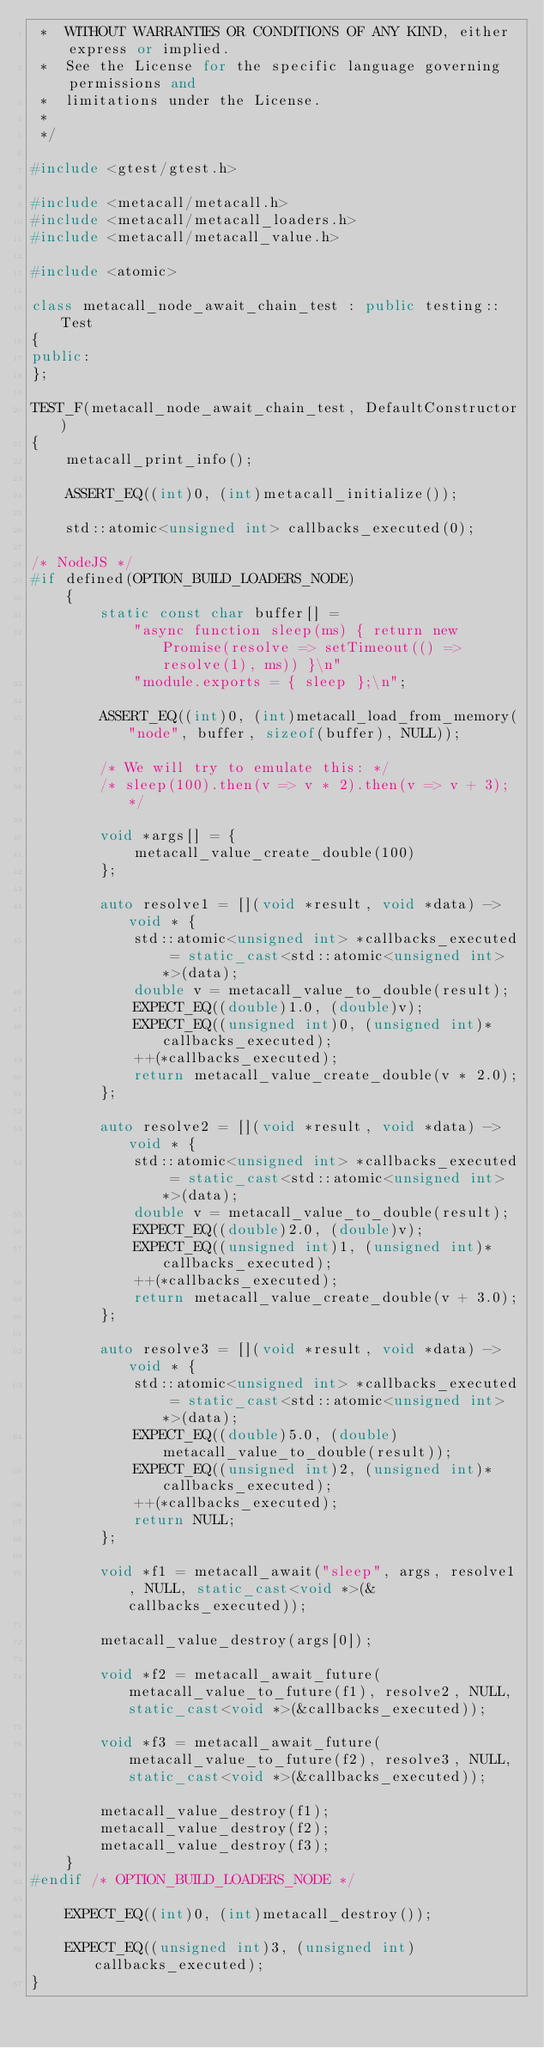Convert code to text. <code><loc_0><loc_0><loc_500><loc_500><_C++_> *	WITHOUT WARRANTIES OR CONDITIONS OF ANY KIND, either express or implied.
 *	See the License for the specific language governing permissions and
 *	limitations under the License.
 *
 */

#include <gtest/gtest.h>

#include <metacall/metacall.h>
#include <metacall/metacall_loaders.h>
#include <metacall/metacall_value.h>

#include <atomic>

class metacall_node_await_chain_test : public testing::Test
{
public:
};

TEST_F(metacall_node_await_chain_test, DefaultConstructor)
{
	metacall_print_info();

	ASSERT_EQ((int)0, (int)metacall_initialize());

	std::atomic<unsigned int> callbacks_executed(0);

/* NodeJS */
#if defined(OPTION_BUILD_LOADERS_NODE)
	{
		static const char buffer[] =
			"async function sleep(ms) { return new Promise(resolve => setTimeout(() => resolve(1), ms)) }\n"
			"module.exports = { sleep };\n";

		ASSERT_EQ((int)0, (int)metacall_load_from_memory("node", buffer, sizeof(buffer), NULL));

		/* We will try to emulate this: */
		/* sleep(100).then(v => v * 2).then(v => v + 3); */

		void *args[] = {
			metacall_value_create_double(100)
		};

		auto resolve1 = [](void *result, void *data) -> void * {
			std::atomic<unsigned int> *callbacks_executed = static_cast<std::atomic<unsigned int> *>(data);
			double v = metacall_value_to_double(result);
			EXPECT_EQ((double)1.0, (double)v);
			EXPECT_EQ((unsigned int)0, (unsigned int)*callbacks_executed);
			++(*callbacks_executed);
			return metacall_value_create_double(v * 2.0);
		};

		auto resolve2 = [](void *result, void *data) -> void * {
			std::atomic<unsigned int> *callbacks_executed = static_cast<std::atomic<unsigned int> *>(data);
			double v = metacall_value_to_double(result);
			EXPECT_EQ((double)2.0, (double)v);
			EXPECT_EQ((unsigned int)1, (unsigned int)*callbacks_executed);
			++(*callbacks_executed);
			return metacall_value_create_double(v + 3.0);
		};

		auto resolve3 = [](void *result, void *data) -> void * {
			std::atomic<unsigned int> *callbacks_executed = static_cast<std::atomic<unsigned int> *>(data);
			EXPECT_EQ((double)5.0, (double)metacall_value_to_double(result));
			EXPECT_EQ((unsigned int)2, (unsigned int)*callbacks_executed);
			++(*callbacks_executed);
			return NULL;
		};

		void *f1 = metacall_await("sleep", args, resolve1, NULL, static_cast<void *>(&callbacks_executed));

		metacall_value_destroy(args[0]);

		void *f2 = metacall_await_future(metacall_value_to_future(f1), resolve2, NULL, static_cast<void *>(&callbacks_executed));

		void *f3 = metacall_await_future(metacall_value_to_future(f2), resolve3, NULL, static_cast<void *>(&callbacks_executed));

		metacall_value_destroy(f1);
		metacall_value_destroy(f2);
		metacall_value_destroy(f3);
	}
#endif /* OPTION_BUILD_LOADERS_NODE */

	EXPECT_EQ((int)0, (int)metacall_destroy());

	EXPECT_EQ((unsigned int)3, (unsigned int)callbacks_executed);
}
</code> 